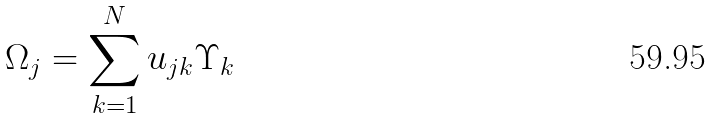<formula> <loc_0><loc_0><loc_500><loc_500>\Omega _ { j } = \sum _ { k = 1 } ^ { N } u _ { j k } \Upsilon _ { k }</formula> 